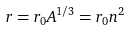Convert formula to latex. <formula><loc_0><loc_0><loc_500><loc_500>r = r _ { 0 } A ^ { 1 / 3 } = r _ { 0 } n ^ { 2 }</formula> 